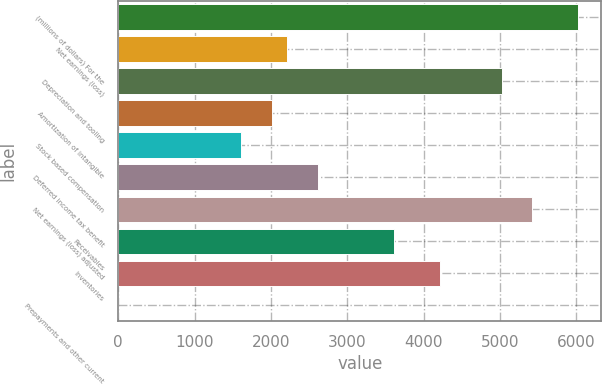Convert chart to OTSL. <chart><loc_0><loc_0><loc_500><loc_500><bar_chart><fcel>(millions of dollars) For the<fcel>Net earnings (loss)<fcel>Depreciation and tooling<fcel>Amortization of intangible<fcel>Stock based compensation<fcel>Deferred income tax benefit<fcel>Net earnings (loss) adjusted<fcel>Receivables<fcel>Inventories<fcel>Prepayments and other current<nl><fcel>6024.6<fcel>2209.78<fcel>5020.7<fcel>2009<fcel>1607.44<fcel>2611.34<fcel>5422.26<fcel>3615.24<fcel>4217.58<fcel>1.2<nl></chart> 